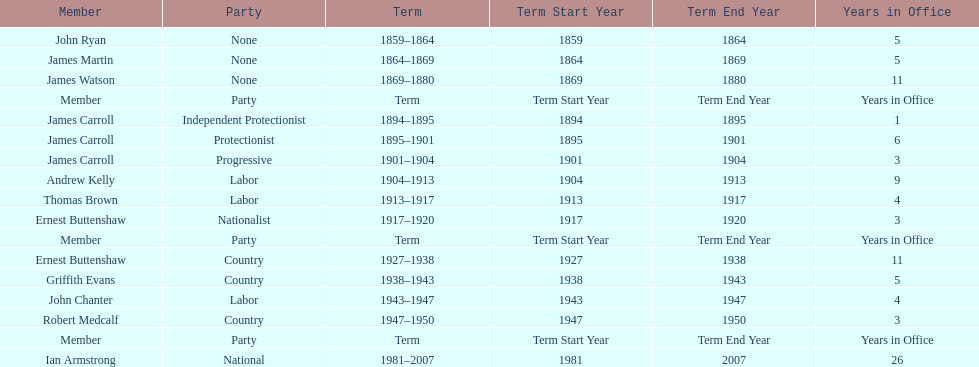How long did ian armstrong serve? 26 years. 